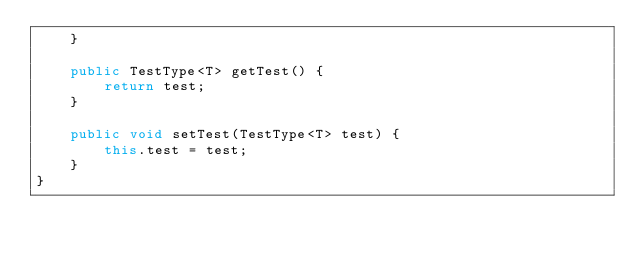Convert code to text. <code><loc_0><loc_0><loc_500><loc_500><_Java_>    }

    public TestType<T> getTest() {
        return test;
    }

    public void setTest(TestType<T> test) {
        this.test = test;
    }
}
</code> 